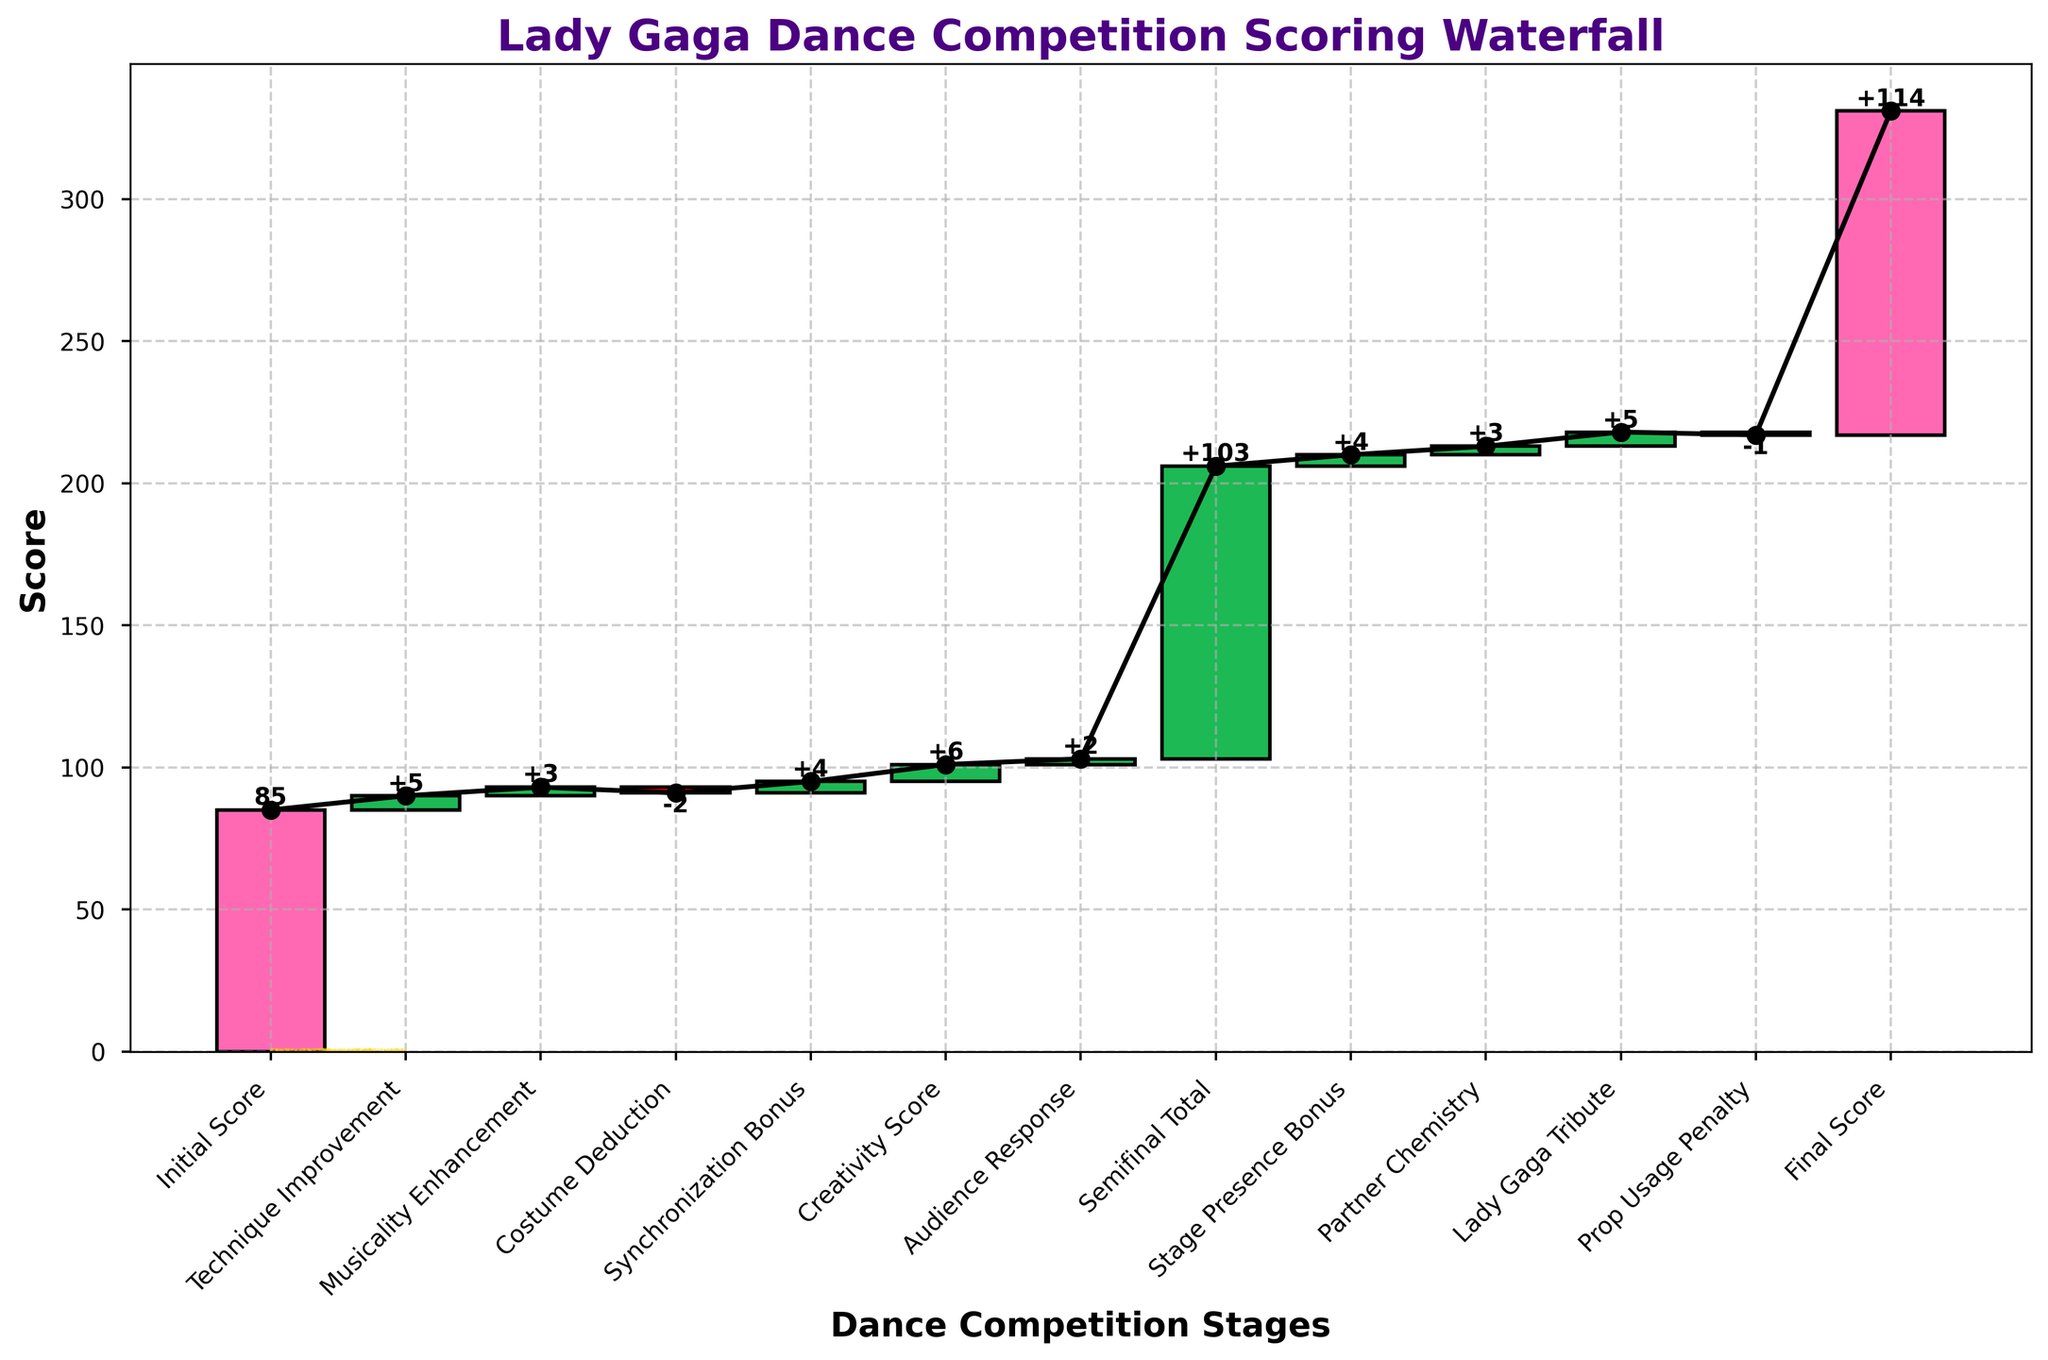What is the title of the chart? The title of the chart is displayed at the top of the figure and reads "Lady Gaga Dance Competition Scoring Waterfall".
Answer: Lady Gaga Dance Competition Scoring Waterfall What is the initial score in the competition? The initial score is the first value on the x-axis labeled "Initial Score". It is not preceded by any adjustments.
Answer: 85 How many positive adjustments were made after the initial score? Positive adjustments are represented by green bars. Counting the green bars after the initial score shows the number of positive adjustments.
Answer: 6 What cumulative score is achieved after the "Costume Deduction"? The cumulative score after each step is shown by the black line plot connecting the bars. The cumulative score after the "Costume Deduction" is shown at the top of its bar.
Answer: 91 Which adjustment had the highest positive impact on the score? The heights of the green bars indicate the size of the positive adjustments. The tallest green bar corresponds to the "Creativity Score".
Answer: Creativity Score How many penalties were applied throughout the competition? Penalties are represented by red bars. Counting the red bars on the chart provides the number of penalties.
Answer: 2 What is the final score of the competition? The final score is the last value on the x-axis labeled "Final Score".
Answer: 114 What was the net change in score from the initial score to the semifinal total? Calculate the difference by subtracting the initial score from the semifinal total: 103 - 85. This net change accounts for all adjustments leading up to the semifinal.
Answer: 18 Which phase contributed more to the score: "Technique Improvement" or "Synchronization Bonus"? Comparing the heights of the green bars for "Technique Improvement" and "Synchronization Bonus", the latter is taller and thus contributed more to the score.
Answer: Synchronization Bonus What's the cumulative score after considering the "Lady Gaga Tribute"? The cumulative score after the "Lady Gaga Tribute" is displayed at the top of its corresponding bar as the black dot in the values.
Answer: 115 